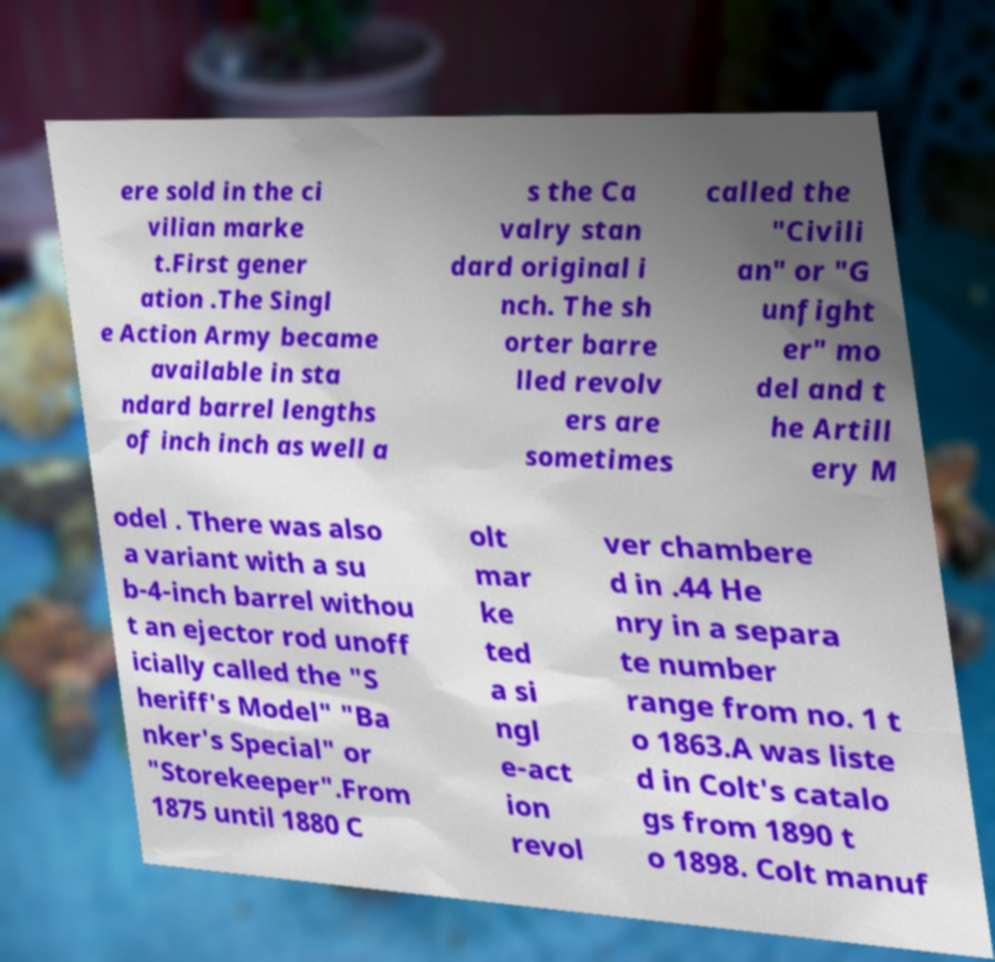Please read and relay the text visible in this image. What does it say? ere sold in the ci vilian marke t.First gener ation .The Singl e Action Army became available in sta ndard barrel lengths of inch inch as well a s the Ca valry stan dard original i nch. The sh orter barre lled revolv ers are sometimes called the "Civili an" or "G unfight er" mo del and t he Artill ery M odel . There was also a variant with a su b-4-inch barrel withou t an ejector rod unoff icially called the "S heriff's Model" "Ba nker's Special" or "Storekeeper".From 1875 until 1880 C olt mar ke ted a si ngl e-act ion revol ver chambere d in .44 He nry in a separa te number range from no. 1 t o 1863.A was liste d in Colt's catalo gs from 1890 t o 1898. Colt manuf 